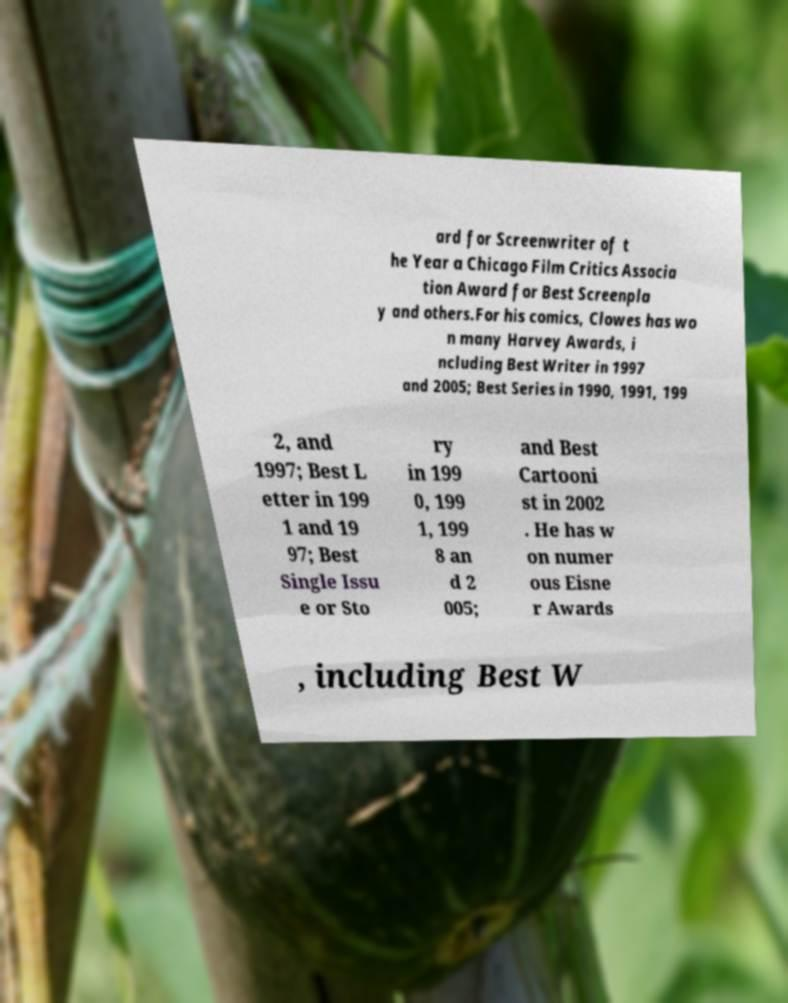Can you read and provide the text displayed in the image?This photo seems to have some interesting text. Can you extract and type it out for me? ard for Screenwriter of t he Year a Chicago Film Critics Associa tion Award for Best Screenpla y and others.For his comics, Clowes has wo n many Harvey Awards, i ncluding Best Writer in 1997 and 2005; Best Series in 1990, 1991, 199 2, and 1997; Best L etter in 199 1 and 19 97; Best Single Issu e or Sto ry in 199 0, 199 1, 199 8 an d 2 005; and Best Cartooni st in 2002 . He has w on numer ous Eisne r Awards , including Best W 